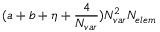<formula> <loc_0><loc_0><loc_500><loc_500>( a + b + \eta + \frac { 4 } { { N _ { v a r } } } ) { N _ { v a r } } ^ { 2 } { N _ { e l e m } }</formula> 